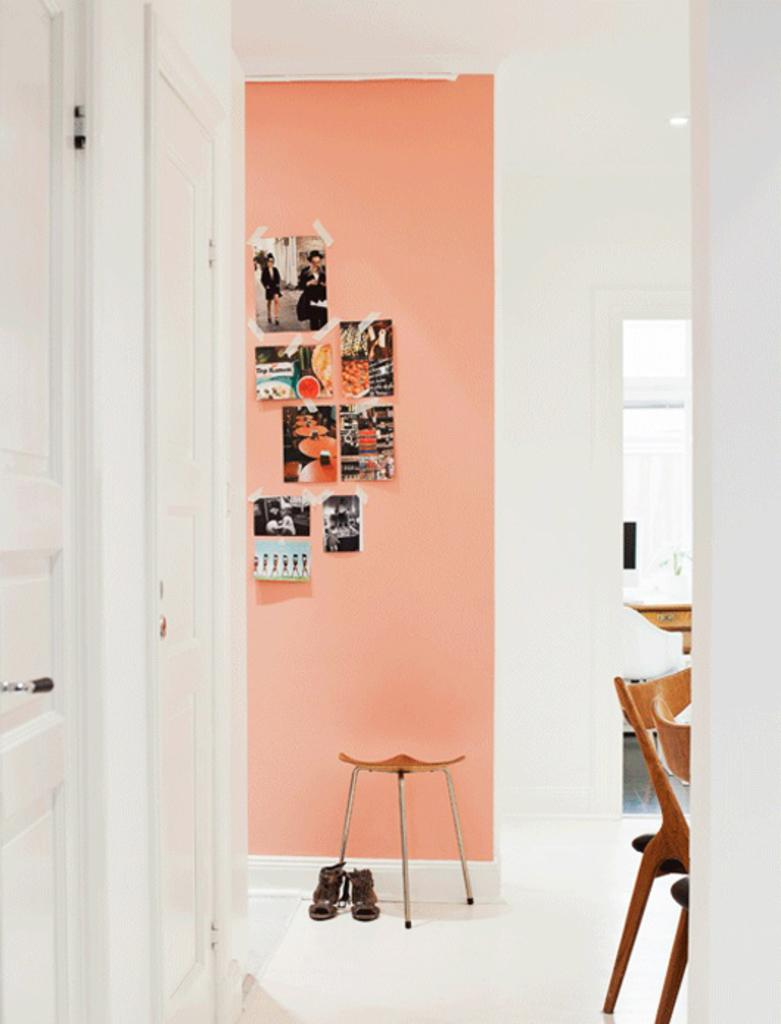What type of furniture can be seen in the image? There are doors and chairs in the image. What can be found on the floor in the image? There is footwear on the floor in the image. What is hanging on the wall in the image? There are photos on a wall in the image. Can you describe the background of the image? There is a chair visible in the background of the image. What type of wine is being served in the image? There is no wine present in the image. How is the honey being used in the image? There is no honey present in the image. 